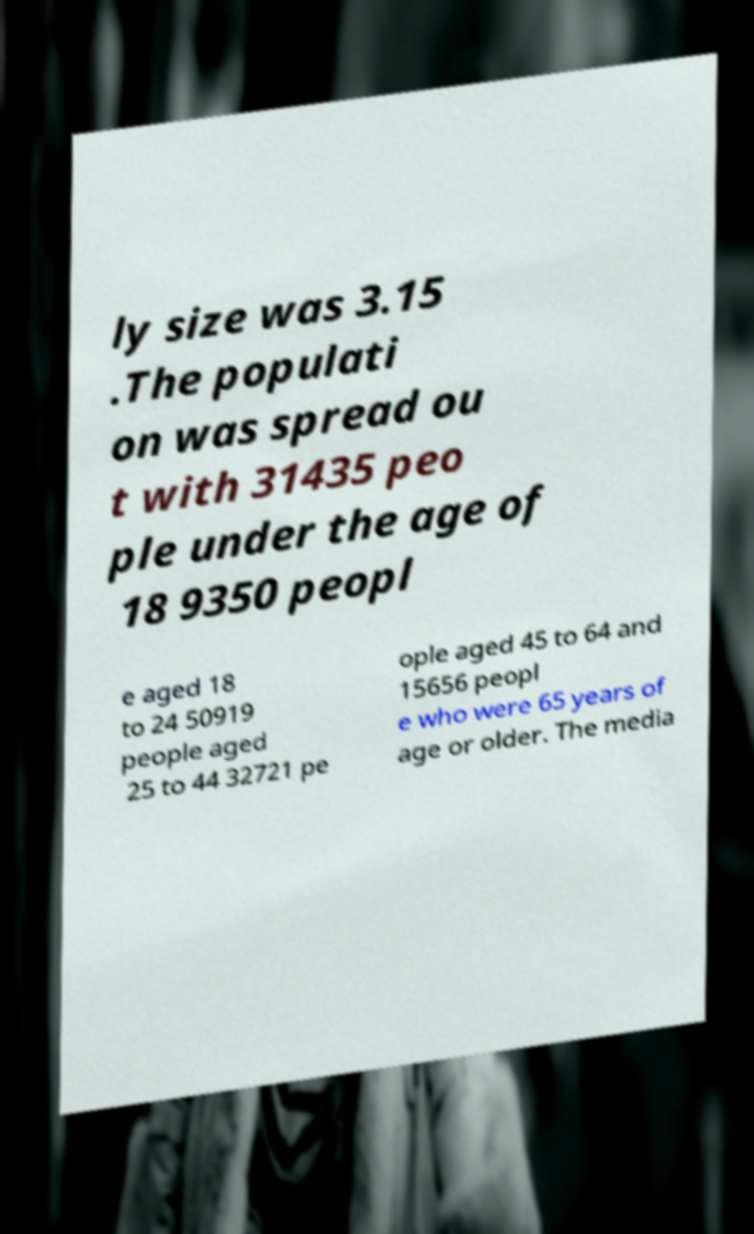What messages or text are displayed in this image? I need them in a readable, typed format. ly size was 3.15 .The populati on was spread ou t with 31435 peo ple under the age of 18 9350 peopl e aged 18 to 24 50919 people aged 25 to 44 32721 pe ople aged 45 to 64 and 15656 peopl e who were 65 years of age or older. The media 